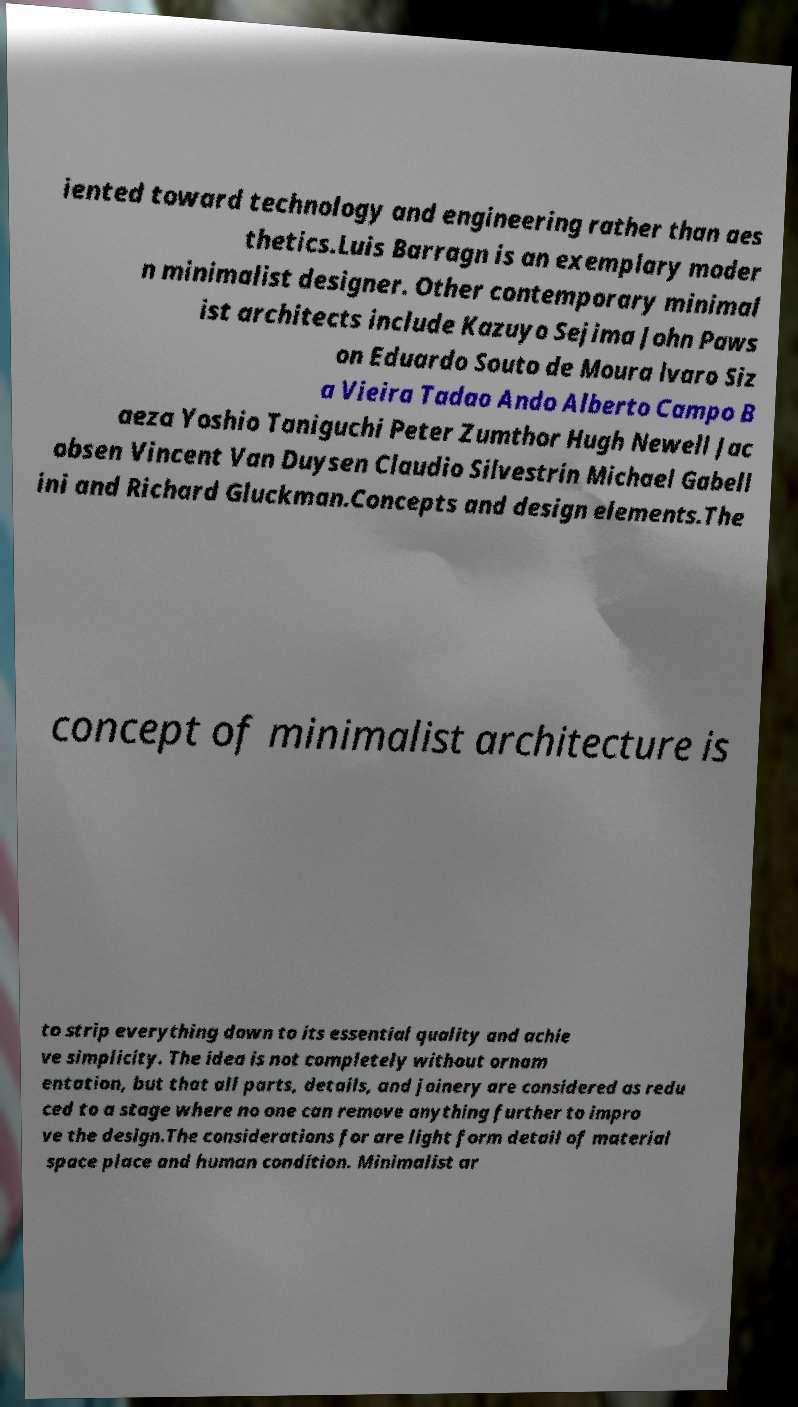Could you assist in decoding the text presented in this image and type it out clearly? iented toward technology and engineering rather than aes thetics.Luis Barragn is an exemplary moder n minimalist designer. Other contemporary minimal ist architects include Kazuyo Sejima John Paws on Eduardo Souto de Moura lvaro Siz a Vieira Tadao Ando Alberto Campo B aeza Yoshio Taniguchi Peter Zumthor Hugh Newell Jac obsen Vincent Van Duysen Claudio Silvestrin Michael Gabell ini and Richard Gluckman.Concepts and design elements.The concept of minimalist architecture is to strip everything down to its essential quality and achie ve simplicity. The idea is not completely without ornam entation, but that all parts, details, and joinery are considered as redu ced to a stage where no one can remove anything further to impro ve the design.The considerations for are light form detail of material space place and human condition. Minimalist ar 